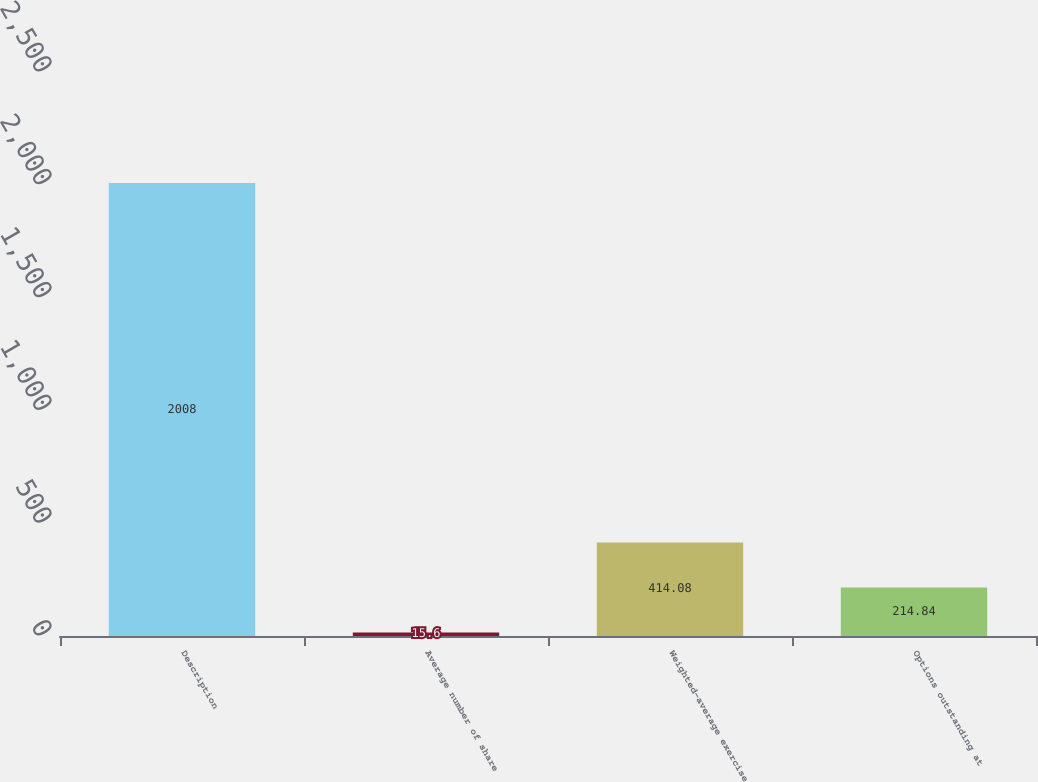Convert chart. <chart><loc_0><loc_0><loc_500><loc_500><bar_chart><fcel>Description<fcel>Average number of share<fcel>Weighted-average exercise<fcel>Options outstanding at<nl><fcel>2008<fcel>15.6<fcel>414.08<fcel>214.84<nl></chart> 